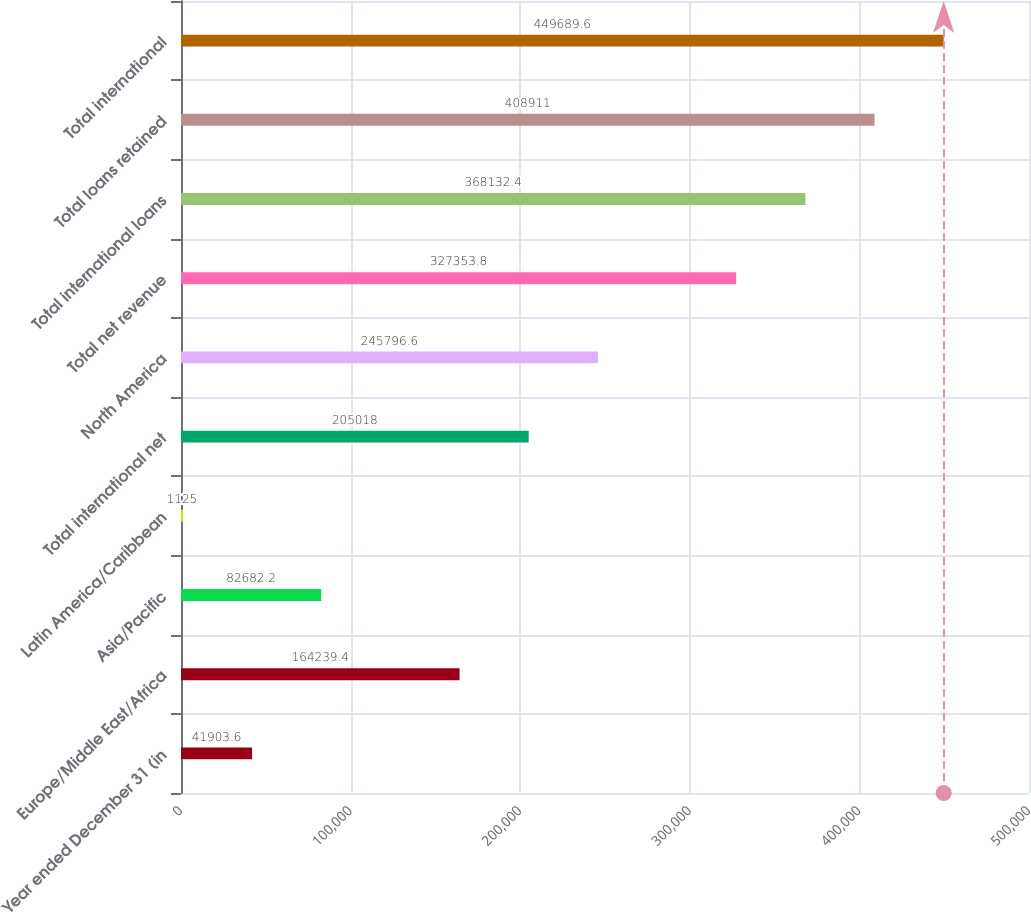<chart> <loc_0><loc_0><loc_500><loc_500><bar_chart><fcel>Year ended December 31 (in<fcel>Europe/Middle East/Africa<fcel>Asia/Pacific<fcel>Latin America/Caribbean<fcel>Total international net<fcel>North America<fcel>Total net revenue<fcel>Total international loans<fcel>Total loans retained<fcel>Total international<nl><fcel>41903.6<fcel>164239<fcel>82682.2<fcel>1125<fcel>205018<fcel>245797<fcel>327354<fcel>368132<fcel>408911<fcel>449690<nl></chart> 